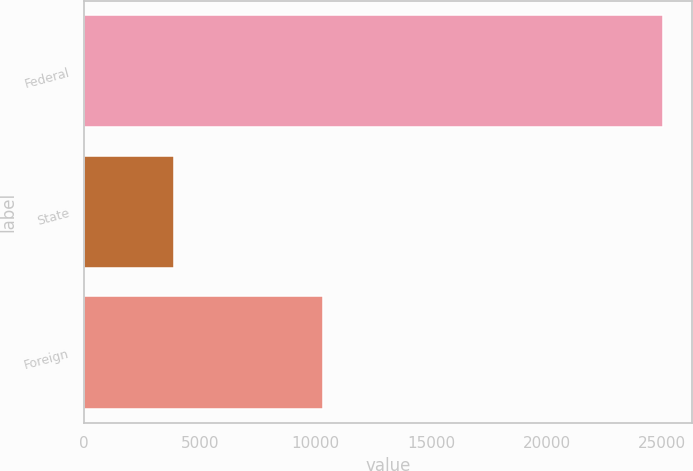<chart> <loc_0><loc_0><loc_500><loc_500><bar_chart><fcel>Federal<fcel>State<fcel>Foreign<nl><fcel>25022<fcel>3905<fcel>10346<nl></chart> 